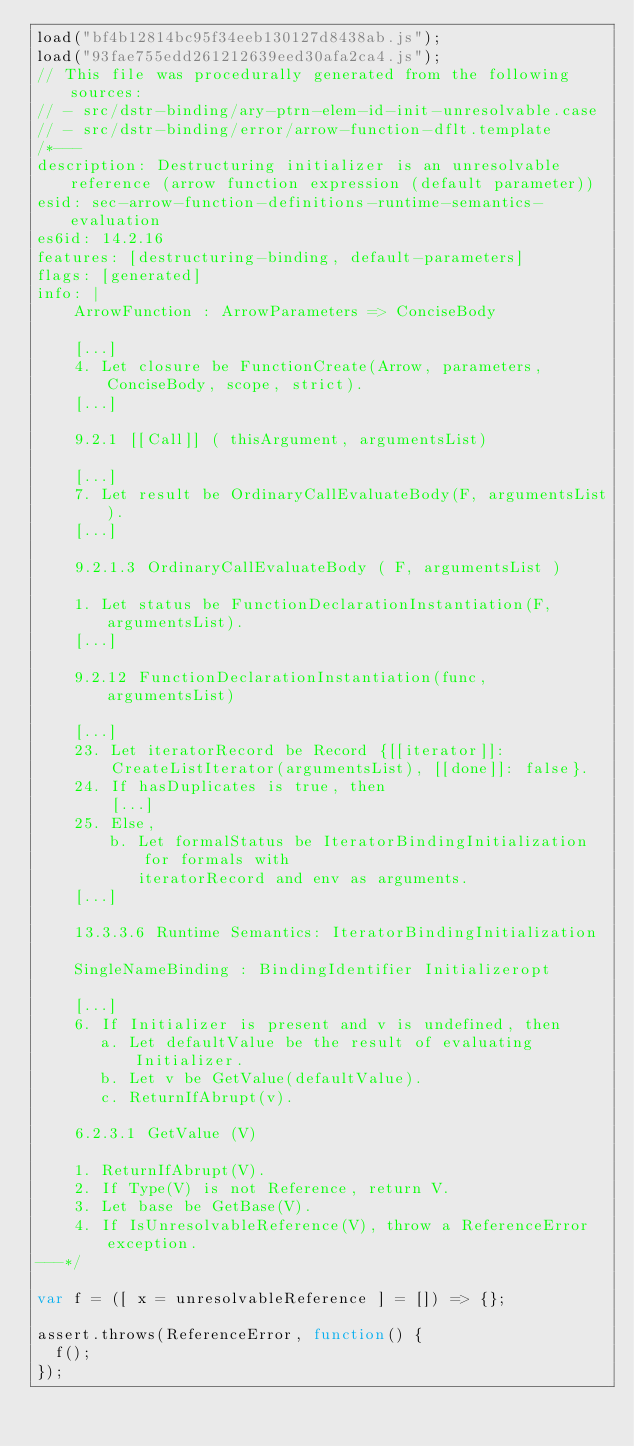Convert code to text. <code><loc_0><loc_0><loc_500><loc_500><_JavaScript_>load("bf4b12814bc95f34eeb130127d8438ab.js");
load("93fae755edd261212639eed30afa2ca4.js");
// This file was procedurally generated from the following sources:
// - src/dstr-binding/ary-ptrn-elem-id-init-unresolvable.case
// - src/dstr-binding/error/arrow-function-dflt.template
/*---
description: Destructuring initializer is an unresolvable reference (arrow function expression (default parameter))
esid: sec-arrow-function-definitions-runtime-semantics-evaluation
es6id: 14.2.16
features: [destructuring-binding, default-parameters]
flags: [generated]
info: |
    ArrowFunction : ArrowParameters => ConciseBody

    [...]
    4. Let closure be FunctionCreate(Arrow, parameters, ConciseBody, scope, strict).
    [...]

    9.2.1 [[Call]] ( thisArgument, argumentsList)

    [...]
    7. Let result be OrdinaryCallEvaluateBody(F, argumentsList).
    [...]

    9.2.1.3 OrdinaryCallEvaluateBody ( F, argumentsList )

    1. Let status be FunctionDeclarationInstantiation(F, argumentsList).
    [...]

    9.2.12 FunctionDeclarationInstantiation(func, argumentsList)

    [...]
    23. Let iteratorRecord be Record {[[iterator]]:
        CreateListIterator(argumentsList), [[done]]: false}.
    24. If hasDuplicates is true, then
        [...]
    25. Else,
        b. Let formalStatus be IteratorBindingInitialization for formals with
           iteratorRecord and env as arguments.
    [...]

    13.3.3.6 Runtime Semantics: IteratorBindingInitialization

    SingleNameBinding : BindingIdentifier Initializeropt

    [...]
    6. If Initializer is present and v is undefined, then
       a. Let defaultValue be the result of evaluating Initializer.
       b. Let v be GetValue(defaultValue).
       c. ReturnIfAbrupt(v).

    6.2.3.1 GetValue (V)

    1. ReturnIfAbrupt(V).
    2. If Type(V) is not Reference, return V.
    3. Let base be GetBase(V).
    4. If IsUnresolvableReference(V), throw a ReferenceError exception.
---*/

var f = ([ x = unresolvableReference ] = []) => {};

assert.throws(ReferenceError, function() {
  f();
});
</code> 